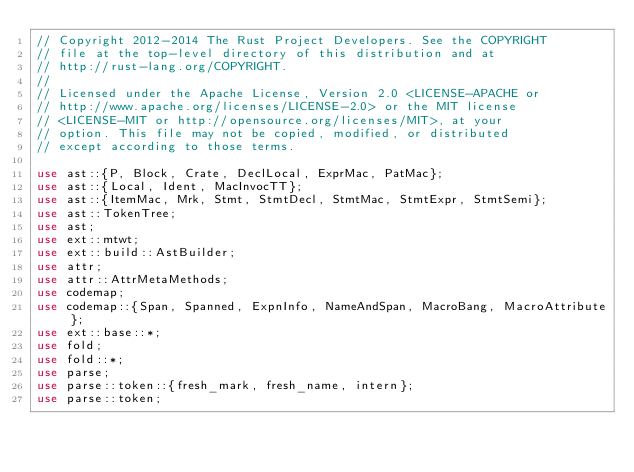Convert code to text. <code><loc_0><loc_0><loc_500><loc_500><_Rust_>// Copyright 2012-2014 The Rust Project Developers. See the COPYRIGHT
// file at the top-level directory of this distribution and at
// http://rust-lang.org/COPYRIGHT.
//
// Licensed under the Apache License, Version 2.0 <LICENSE-APACHE or
// http://www.apache.org/licenses/LICENSE-2.0> or the MIT license
// <LICENSE-MIT or http://opensource.org/licenses/MIT>, at your
// option. This file may not be copied, modified, or distributed
// except according to those terms.

use ast::{P, Block, Crate, DeclLocal, ExprMac, PatMac};
use ast::{Local, Ident, MacInvocTT};
use ast::{ItemMac, Mrk, Stmt, StmtDecl, StmtMac, StmtExpr, StmtSemi};
use ast::TokenTree;
use ast;
use ext::mtwt;
use ext::build::AstBuilder;
use attr;
use attr::AttrMetaMethods;
use codemap;
use codemap::{Span, Spanned, ExpnInfo, NameAndSpan, MacroBang, MacroAttribute};
use ext::base::*;
use fold;
use fold::*;
use parse;
use parse::token::{fresh_mark, fresh_name, intern};
use parse::token;</code> 